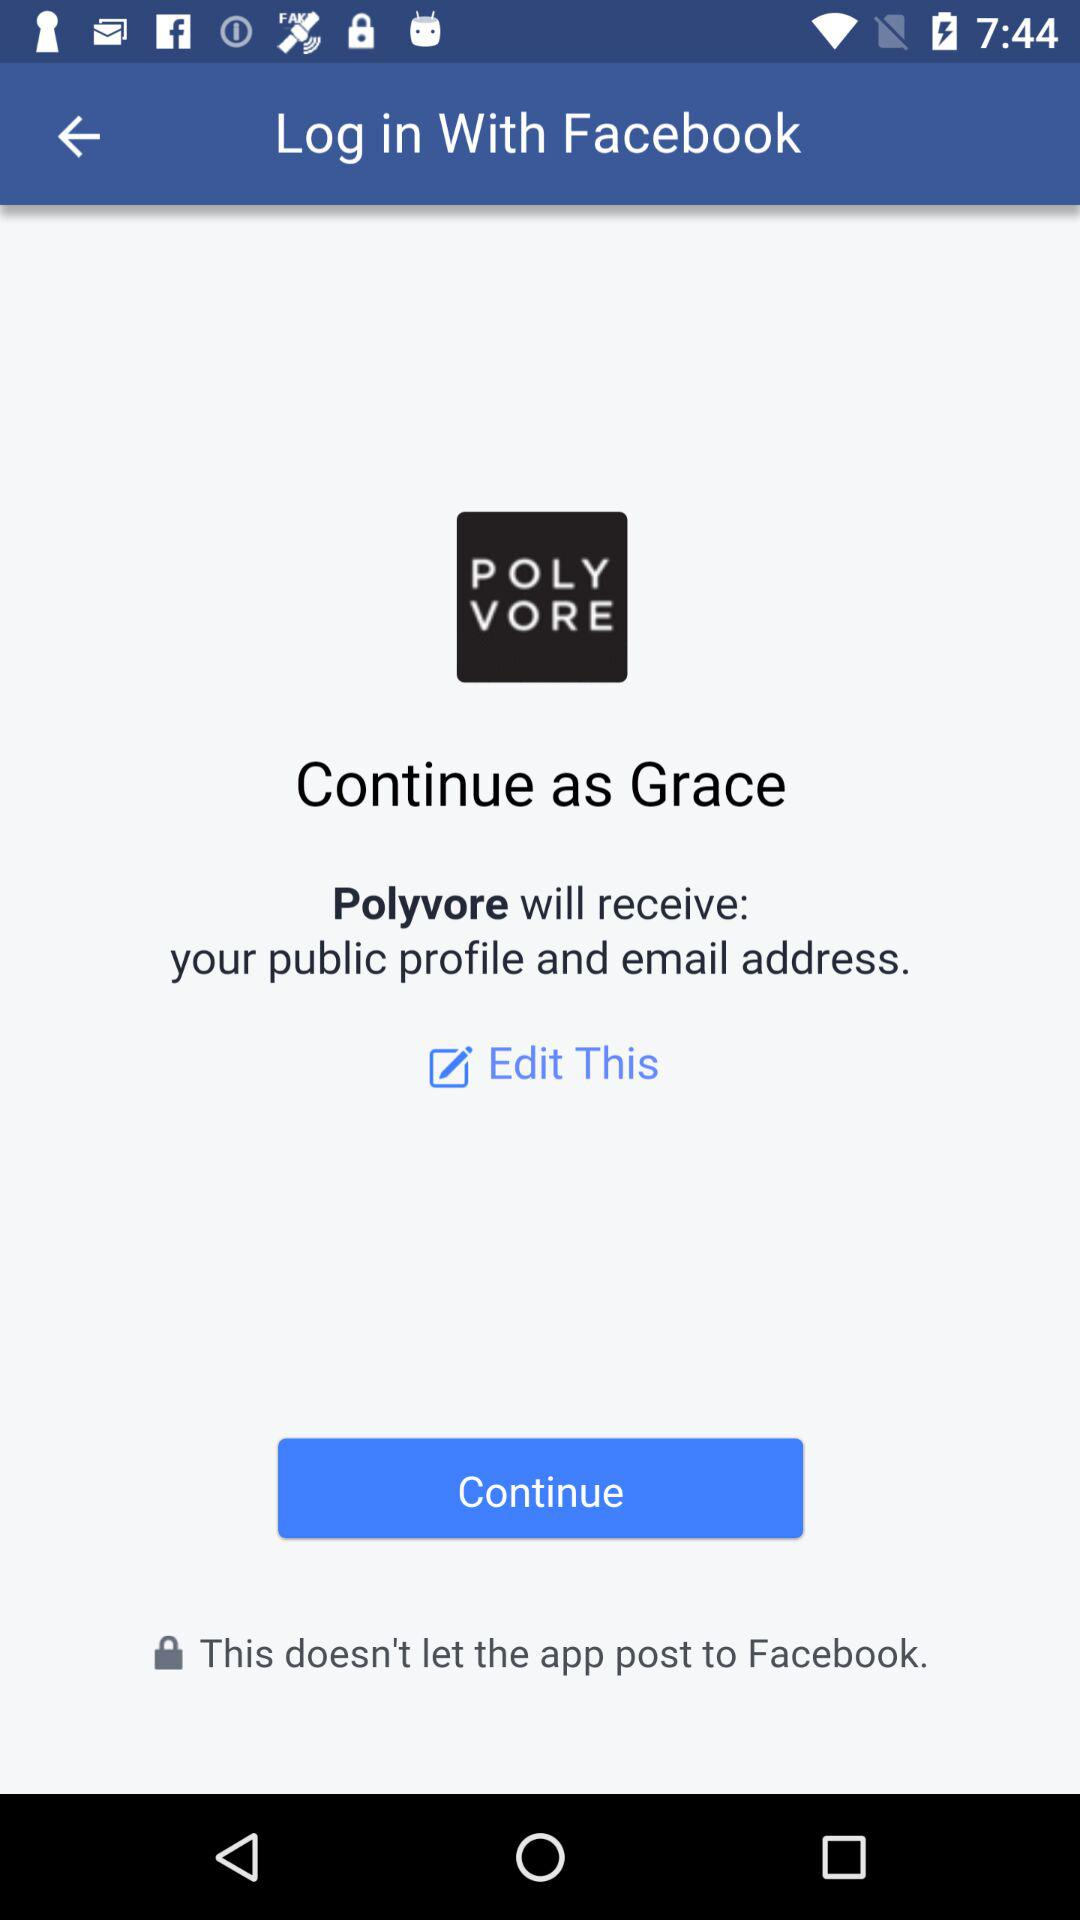What is the name of the user? The name of the user is "Grace". 